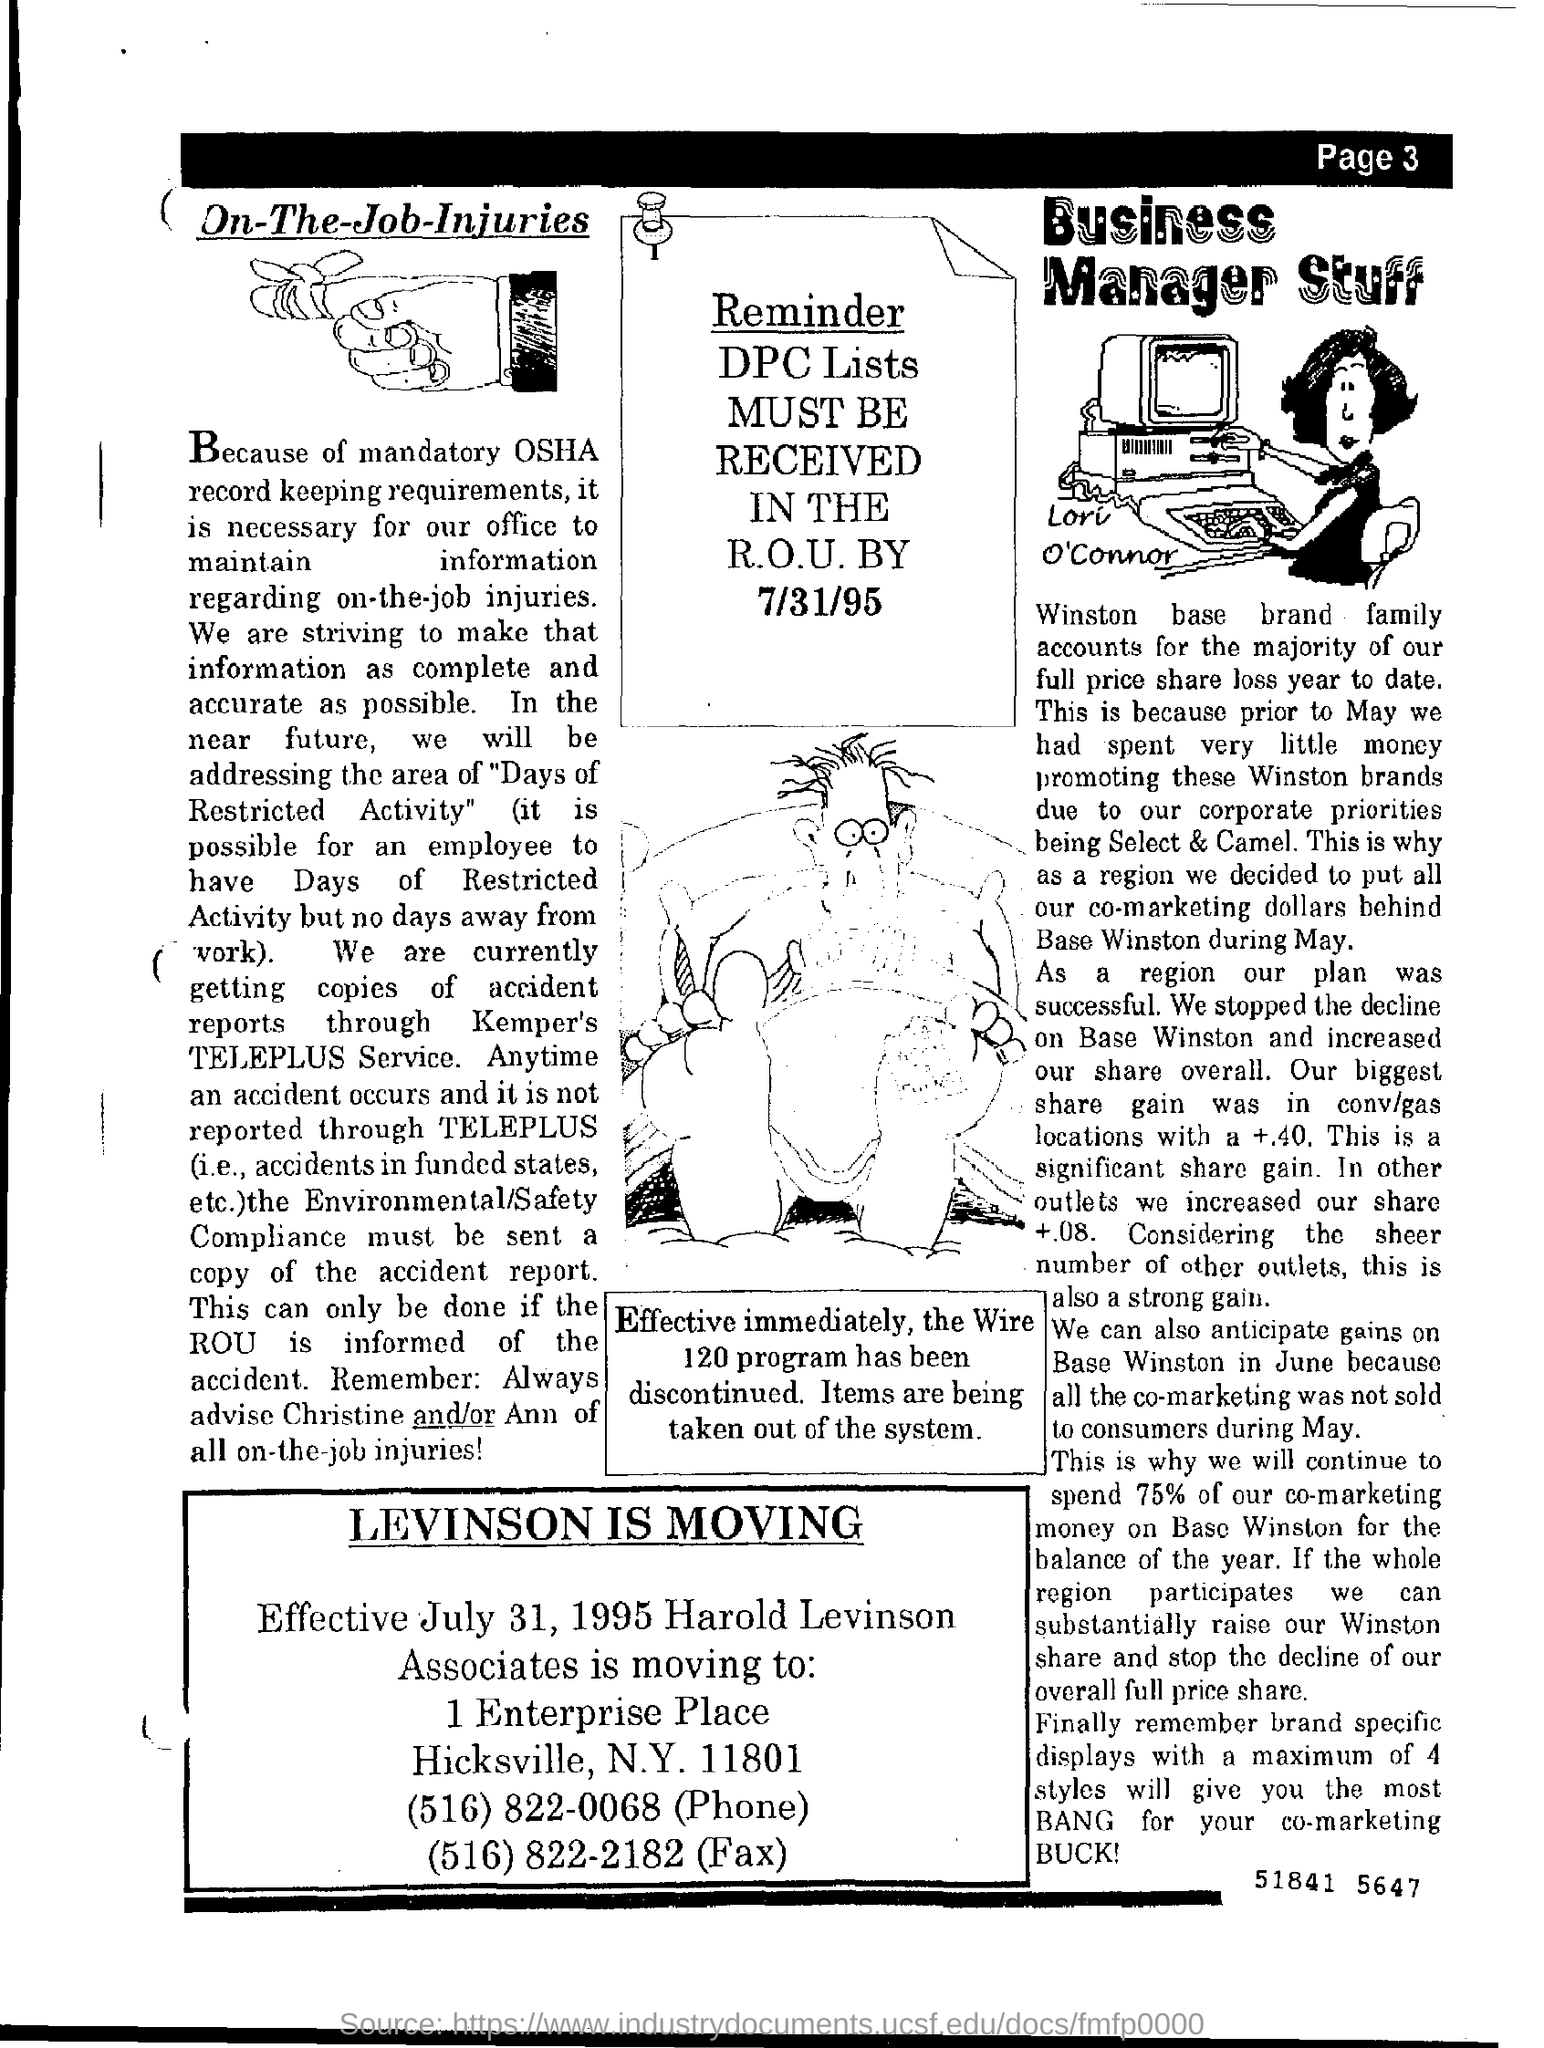Outline some significant characteristics in this image. The phone number mentioned in the document is (516) 822-0068. 